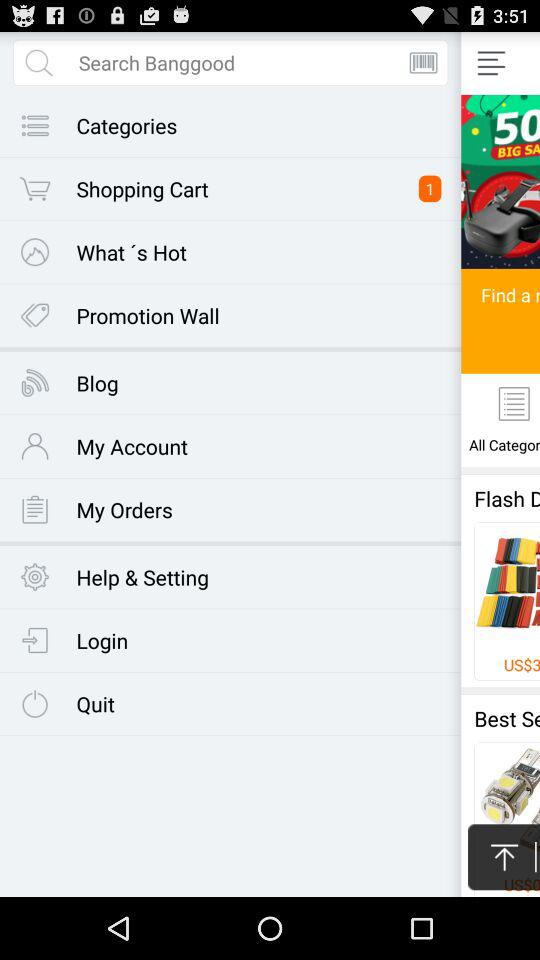How many people like the product? The product is liked by 606 people. 